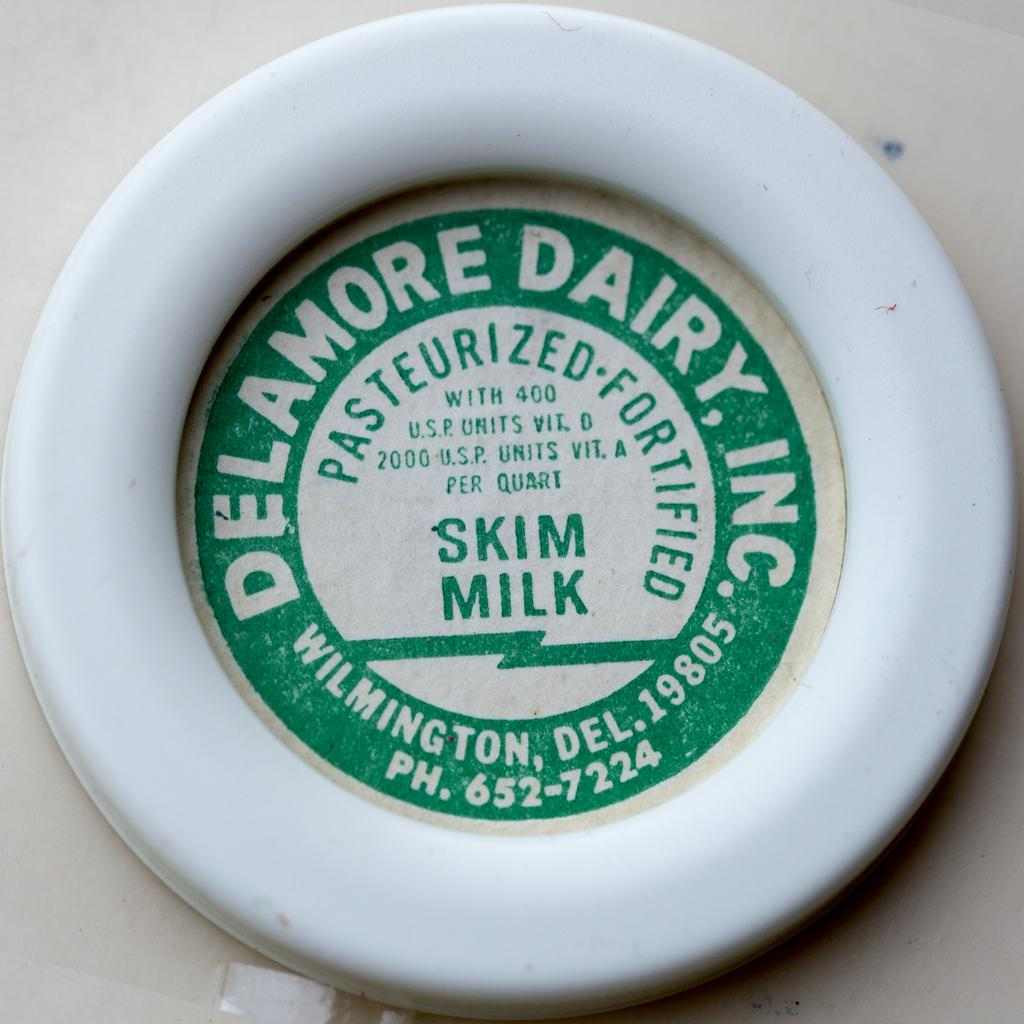What is the main subject of the image? There is an object in the center of the image. Can you describe the object in the image? The object has text on it. How is the net used in the image? There is no net present in the image; it only features an object with text on it. 